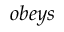<formula> <loc_0><loc_0><loc_500><loc_500>o b e y s</formula> 